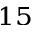<formula> <loc_0><loc_0><loc_500><loc_500>^ { 1 5 }</formula> 